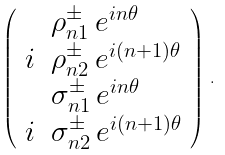Convert formula to latex. <formula><loc_0><loc_0><loc_500><loc_500>\left ( \begin{array} { r l } & \rho _ { n 1 } ^ { \pm } \, e ^ { i n \theta } \\ i & \rho _ { n 2 } ^ { \pm } \, e ^ { i ( n + 1 ) \theta } \\ & \sigma _ { n 1 } ^ { \pm } \, e ^ { i n \theta } \\ i & \sigma _ { n 2 } ^ { \pm } \, e ^ { i ( n + 1 ) \theta } \end{array} \right ) \, .</formula> 